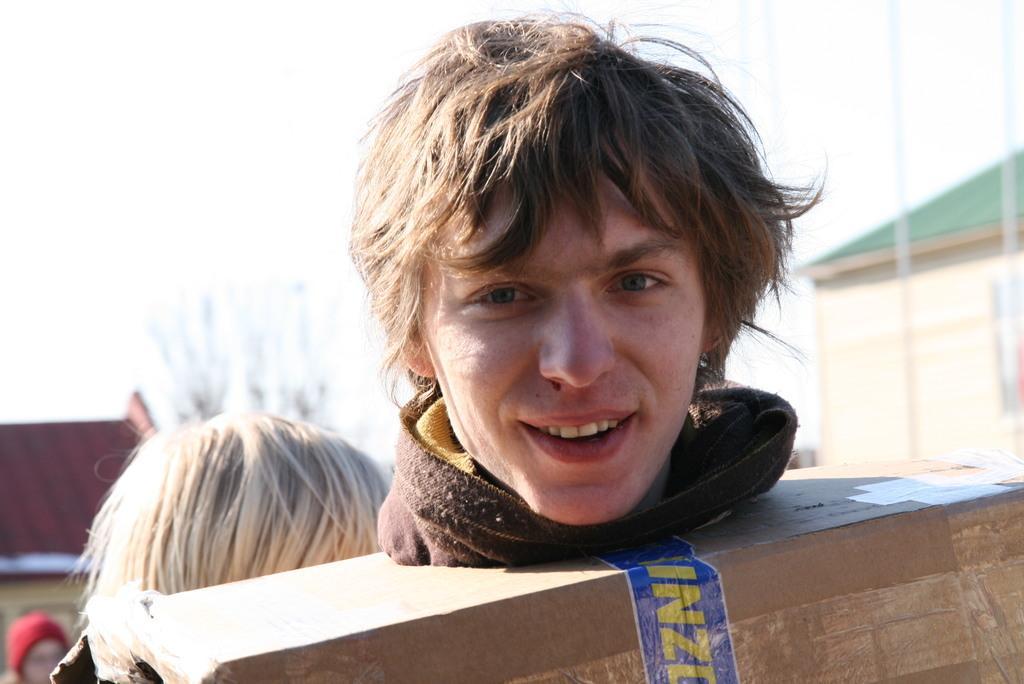Describe this image in one or two sentences. In this picture, there is a man wearing a carton box. Behind him, there is a woman. In the background, there are buildings. 